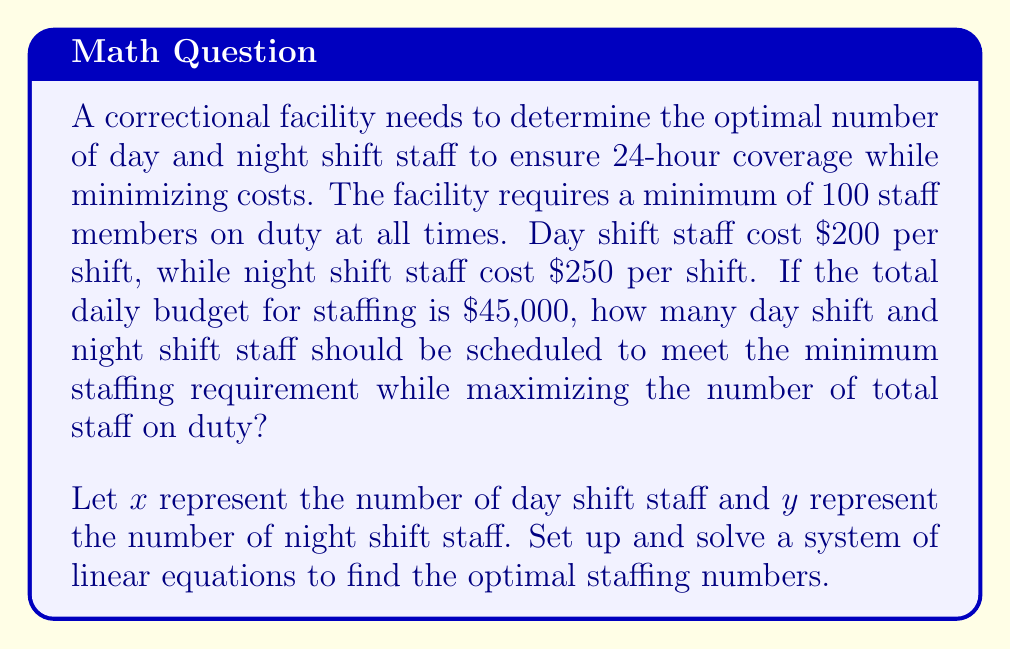Show me your answer to this math problem. Let's approach this step-by-step:

1) First, we need to set up our system of equations based on the given information:

   Equation 1 (minimum staffing requirement): $x + y = 100$
   Equation 2 (budget constraint): $200x + 250y = 45000$

2) We can solve this system using substitution method. Let's start by expressing $y$ in terms of $x$ from Equation 1:

   $y = 100 - x$

3) Now, substitute this expression for $y$ into Equation 2:

   $200x + 250(100 - x) = 45000$

4) Simplify:

   $200x + 25000 - 250x = 45000$
   $-50x + 25000 = 45000$

5) Subtract 25000 from both sides:

   $-50x = 20000$

6) Divide both sides by -50:

   $x = -400$

7) However, we can't have a negative number of staff. This means we need to maximize $x$ within our constraints.

8) Let's go back to our original equations and solve for $y$ when $x = 0$:

   $200(0) + 250y = 45000$
   $250y = 45000$
   $y = 180$

9) This satisfies our minimum staffing requirement ($180 > 100$), but we need to check if we can increase $x$ and decrease $y$ while still meeting both constraints.

10) Let's try $x = 75$ and $y = 25$:

    $75 + 25 = 100$ (meets minimum staffing)
    $200(75) + 250(25) = 15000 + 6250 = 21250 < 45000$ (within budget)

This solution meets both constraints and maximizes the number of day shift staff (which are less expensive), allowing for more total staff on duty within the budget.
Answer: 75 day shift staff, 25 night shift staff 